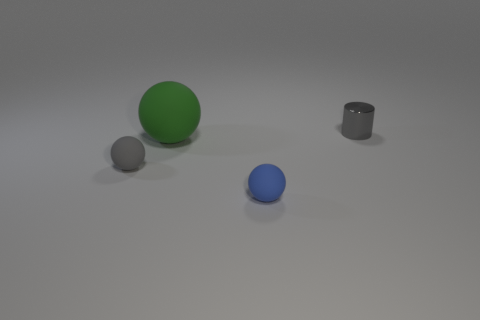How many big objects are brown metallic cylinders or metal things?
Your answer should be compact. 0. The small gray thing in front of the large sphere has what shape?
Ensure brevity in your answer.  Sphere. Is there a rubber object that has the same color as the small shiny cylinder?
Provide a short and direct response. Yes. There is a gray object in front of the gray cylinder; is its size the same as the matte thing behind the tiny gray matte ball?
Your answer should be very brief. No. Are there more small metallic cylinders in front of the large matte sphere than green balls right of the tiny blue thing?
Give a very brief answer. No. Is there a green thing made of the same material as the small gray sphere?
Your answer should be very brief. Yes. What material is the tiny object that is both on the right side of the gray matte thing and in front of the gray cylinder?
Make the answer very short. Rubber. The small cylinder is what color?
Your answer should be compact. Gray. How many tiny blue matte things have the same shape as the green matte object?
Make the answer very short. 1. Are the small gray thing that is to the left of the gray cylinder and the cylinder that is behind the large thing made of the same material?
Provide a succinct answer. No. 